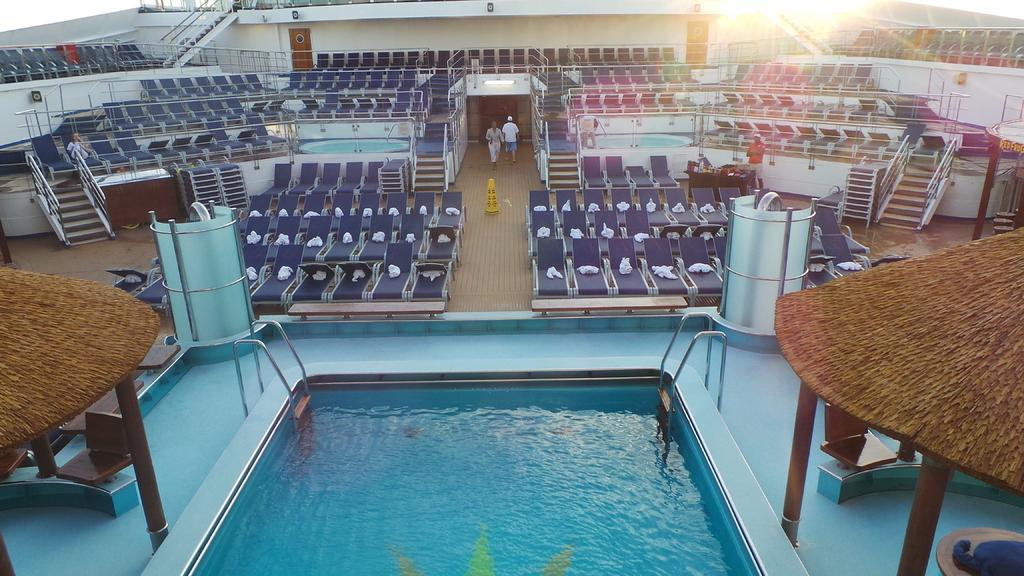How would you summarize this image in a sentence or two? In this image in the front there is a swimming pool. There are tents and there are empty chairs, in the center there are empty seats and there is a person standing and there is a person laying. In the background there are persons walking and there are empty seats, there is a wall. In the center there are steps and there is a stand which is yellow in colour. 